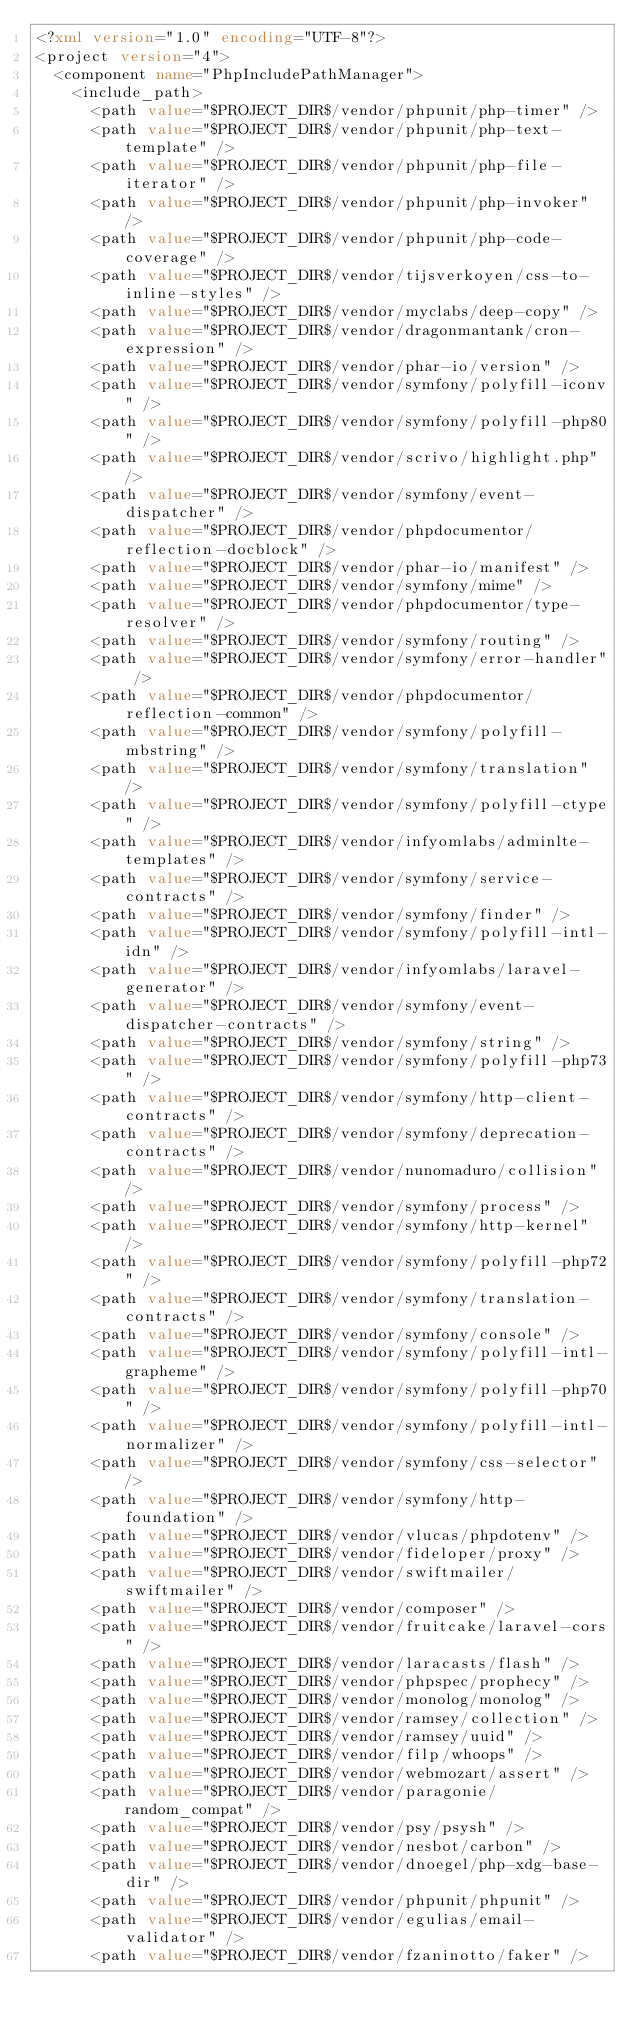<code> <loc_0><loc_0><loc_500><loc_500><_XML_><?xml version="1.0" encoding="UTF-8"?>
<project version="4">
  <component name="PhpIncludePathManager">
    <include_path>
      <path value="$PROJECT_DIR$/vendor/phpunit/php-timer" />
      <path value="$PROJECT_DIR$/vendor/phpunit/php-text-template" />
      <path value="$PROJECT_DIR$/vendor/phpunit/php-file-iterator" />
      <path value="$PROJECT_DIR$/vendor/phpunit/php-invoker" />
      <path value="$PROJECT_DIR$/vendor/phpunit/php-code-coverage" />
      <path value="$PROJECT_DIR$/vendor/tijsverkoyen/css-to-inline-styles" />
      <path value="$PROJECT_DIR$/vendor/myclabs/deep-copy" />
      <path value="$PROJECT_DIR$/vendor/dragonmantank/cron-expression" />
      <path value="$PROJECT_DIR$/vendor/phar-io/version" />
      <path value="$PROJECT_DIR$/vendor/symfony/polyfill-iconv" />
      <path value="$PROJECT_DIR$/vendor/symfony/polyfill-php80" />
      <path value="$PROJECT_DIR$/vendor/scrivo/highlight.php" />
      <path value="$PROJECT_DIR$/vendor/symfony/event-dispatcher" />
      <path value="$PROJECT_DIR$/vendor/phpdocumentor/reflection-docblock" />
      <path value="$PROJECT_DIR$/vendor/phar-io/manifest" />
      <path value="$PROJECT_DIR$/vendor/symfony/mime" />
      <path value="$PROJECT_DIR$/vendor/phpdocumentor/type-resolver" />
      <path value="$PROJECT_DIR$/vendor/symfony/routing" />
      <path value="$PROJECT_DIR$/vendor/symfony/error-handler" />
      <path value="$PROJECT_DIR$/vendor/phpdocumentor/reflection-common" />
      <path value="$PROJECT_DIR$/vendor/symfony/polyfill-mbstring" />
      <path value="$PROJECT_DIR$/vendor/symfony/translation" />
      <path value="$PROJECT_DIR$/vendor/symfony/polyfill-ctype" />
      <path value="$PROJECT_DIR$/vendor/infyomlabs/adminlte-templates" />
      <path value="$PROJECT_DIR$/vendor/symfony/service-contracts" />
      <path value="$PROJECT_DIR$/vendor/symfony/finder" />
      <path value="$PROJECT_DIR$/vendor/symfony/polyfill-intl-idn" />
      <path value="$PROJECT_DIR$/vendor/infyomlabs/laravel-generator" />
      <path value="$PROJECT_DIR$/vendor/symfony/event-dispatcher-contracts" />
      <path value="$PROJECT_DIR$/vendor/symfony/string" />
      <path value="$PROJECT_DIR$/vendor/symfony/polyfill-php73" />
      <path value="$PROJECT_DIR$/vendor/symfony/http-client-contracts" />
      <path value="$PROJECT_DIR$/vendor/symfony/deprecation-contracts" />
      <path value="$PROJECT_DIR$/vendor/nunomaduro/collision" />
      <path value="$PROJECT_DIR$/vendor/symfony/process" />
      <path value="$PROJECT_DIR$/vendor/symfony/http-kernel" />
      <path value="$PROJECT_DIR$/vendor/symfony/polyfill-php72" />
      <path value="$PROJECT_DIR$/vendor/symfony/translation-contracts" />
      <path value="$PROJECT_DIR$/vendor/symfony/console" />
      <path value="$PROJECT_DIR$/vendor/symfony/polyfill-intl-grapheme" />
      <path value="$PROJECT_DIR$/vendor/symfony/polyfill-php70" />
      <path value="$PROJECT_DIR$/vendor/symfony/polyfill-intl-normalizer" />
      <path value="$PROJECT_DIR$/vendor/symfony/css-selector" />
      <path value="$PROJECT_DIR$/vendor/symfony/http-foundation" />
      <path value="$PROJECT_DIR$/vendor/vlucas/phpdotenv" />
      <path value="$PROJECT_DIR$/vendor/fideloper/proxy" />
      <path value="$PROJECT_DIR$/vendor/swiftmailer/swiftmailer" />
      <path value="$PROJECT_DIR$/vendor/composer" />
      <path value="$PROJECT_DIR$/vendor/fruitcake/laravel-cors" />
      <path value="$PROJECT_DIR$/vendor/laracasts/flash" />
      <path value="$PROJECT_DIR$/vendor/phpspec/prophecy" />
      <path value="$PROJECT_DIR$/vendor/monolog/monolog" />
      <path value="$PROJECT_DIR$/vendor/ramsey/collection" />
      <path value="$PROJECT_DIR$/vendor/ramsey/uuid" />
      <path value="$PROJECT_DIR$/vendor/filp/whoops" />
      <path value="$PROJECT_DIR$/vendor/webmozart/assert" />
      <path value="$PROJECT_DIR$/vendor/paragonie/random_compat" />
      <path value="$PROJECT_DIR$/vendor/psy/psysh" />
      <path value="$PROJECT_DIR$/vendor/nesbot/carbon" />
      <path value="$PROJECT_DIR$/vendor/dnoegel/php-xdg-base-dir" />
      <path value="$PROJECT_DIR$/vendor/phpunit/phpunit" />
      <path value="$PROJECT_DIR$/vendor/egulias/email-validator" />
      <path value="$PROJECT_DIR$/vendor/fzaninotto/faker" /></code> 